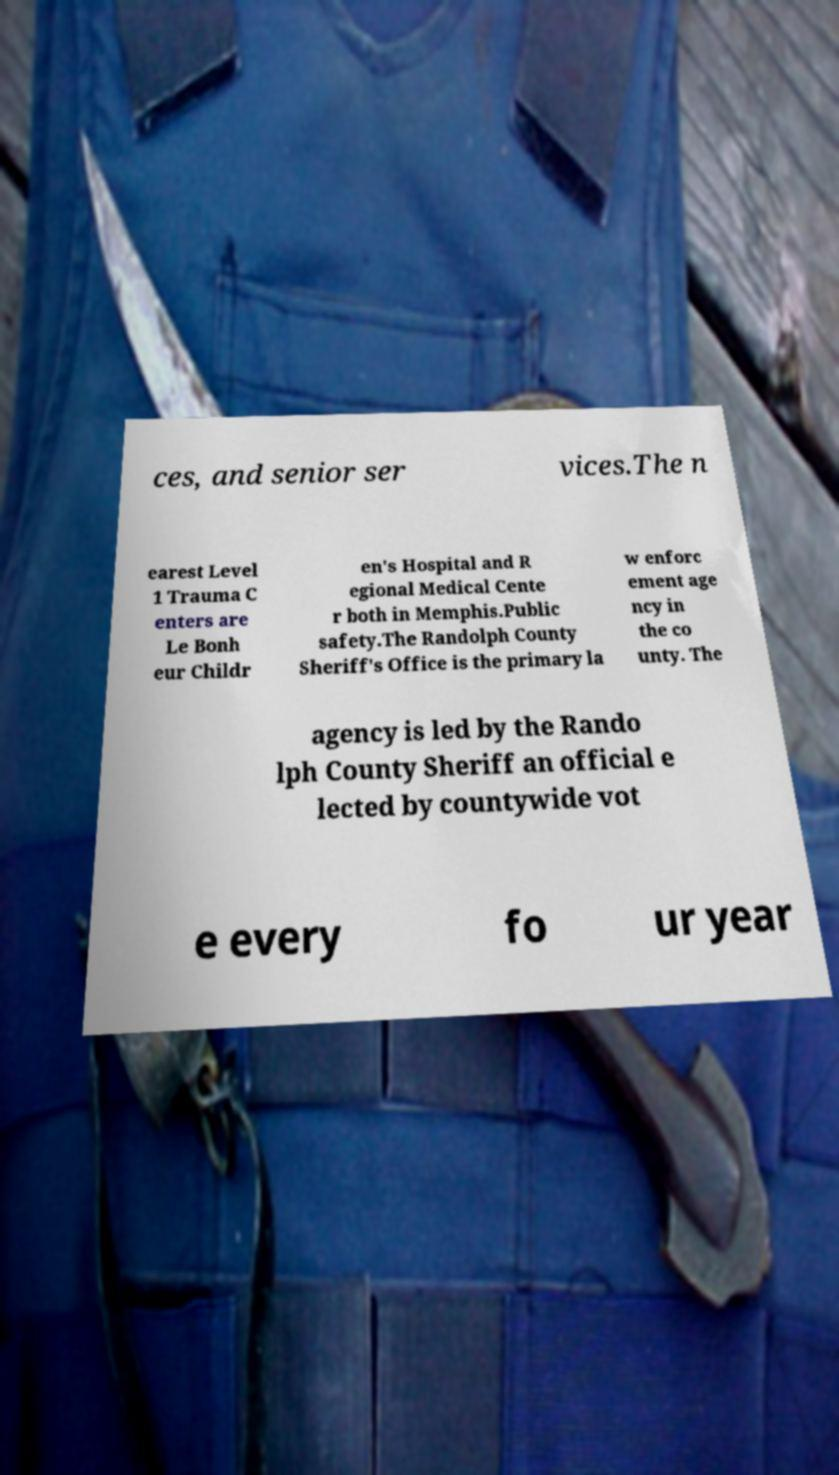What messages or text are displayed in this image? I need them in a readable, typed format. ces, and senior ser vices.The n earest Level 1 Trauma C enters are Le Bonh eur Childr en's Hospital and R egional Medical Cente r both in Memphis.Public safety.The Randolph County Sheriff's Office is the primary la w enforc ement age ncy in the co unty. The agency is led by the Rando lph County Sheriff an official e lected by countywide vot e every fo ur year 